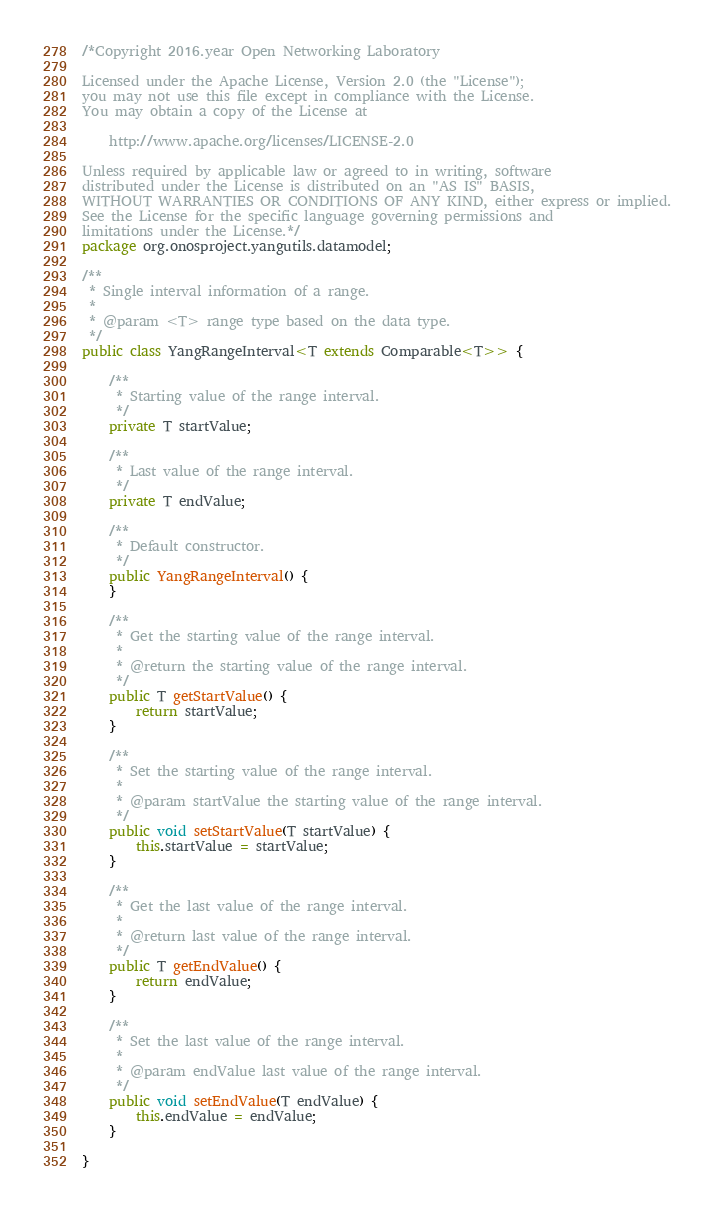<code> <loc_0><loc_0><loc_500><loc_500><_Java_>/*Copyright 2016.year Open Networking Laboratory

Licensed under the Apache License, Version 2.0 (the "License");
you may not use this file except in compliance with the License.
You may obtain a copy of the License at

    http://www.apache.org/licenses/LICENSE-2.0

Unless required by applicable law or agreed to in writing, software
distributed under the License is distributed on an "AS IS" BASIS,
WITHOUT WARRANTIES OR CONDITIONS OF ANY KIND, either express or implied.
See the License for the specific language governing permissions and
limitations under the License.*/
package org.onosproject.yangutils.datamodel;

/**
 * Single interval information of a range.
 *
 * @param <T> range type based on the data type.
 */
public class YangRangeInterval<T extends Comparable<T>> {

    /**
     * Starting value of the range interval.
     */
    private T startValue;

    /**
     * Last value of the range interval.
     */
    private T endValue;

    /**
     * Default constructor.
     */
    public YangRangeInterval() {
    }

    /**
     * Get the starting value of the range interval.
     *
     * @return the starting value of the range interval.
     */
    public T getStartValue() {
        return startValue;
    }

    /**
     * Set the starting value of the range interval.
     *
     * @param startValue the starting value of the range interval.
     */
    public void setStartValue(T startValue) {
        this.startValue = startValue;
    }

    /**
     * Get the last value of the range interval.
     *
     * @return last value of the range interval.
     */
    public T getEndValue() {
        return endValue;
    }

    /**
     * Set the last value of the range interval.
     *
     * @param endValue last value of the range interval.
     */
    public void setEndValue(T endValue) {
        this.endValue = endValue;
    }

}
</code> 